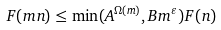Convert formula to latex. <formula><loc_0><loc_0><loc_500><loc_500>F ( m n ) \leq \min ( A ^ { \Omega ( m ) } , B m ^ { \varepsilon } ) F ( n )</formula> 